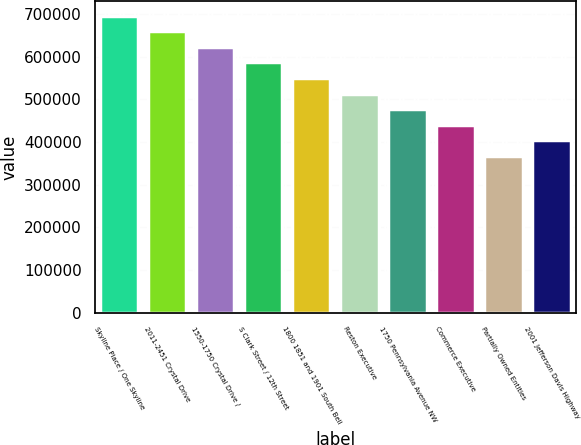Convert chart. <chart><loc_0><loc_0><loc_500><loc_500><bar_chart><fcel>Skyline Place / One Skyline<fcel>2011-2451 Crystal Drive<fcel>1550-1750 Crystal Drive /<fcel>S Clark Street / 12th Street<fcel>1800 1851 and 1901 South Bell<fcel>Reston Executive<fcel>1750 Pennsylvania Avenue NW<fcel>Commerce Executive<fcel>Partially Owned Entities<fcel>2001 Jefferson Davis Highway<nl><fcel>695600<fcel>659200<fcel>622800<fcel>586400<fcel>550000<fcel>513600<fcel>477200<fcel>440800<fcel>368000<fcel>404400<nl></chart> 